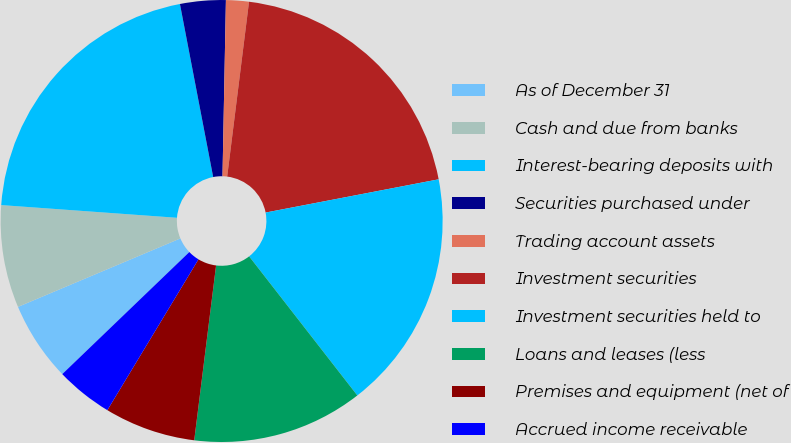Convert chart. <chart><loc_0><loc_0><loc_500><loc_500><pie_chart><fcel>As of December 31<fcel>Cash and due from banks<fcel>Interest-bearing deposits with<fcel>Securities purchased under<fcel>Trading account assets<fcel>Investment securities<fcel>Investment securities held to<fcel>Loans and leases (less<fcel>Premises and equipment (net of<fcel>Accrued income receivable<nl><fcel>5.83%<fcel>7.5%<fcel>20.83%<fcel>3.33%<fcel>1.67%<fcel>20.0%<fcel>17.5%<fcel>12.5%<fcel>6.67%<fcel>4.17%<nl></chart> 